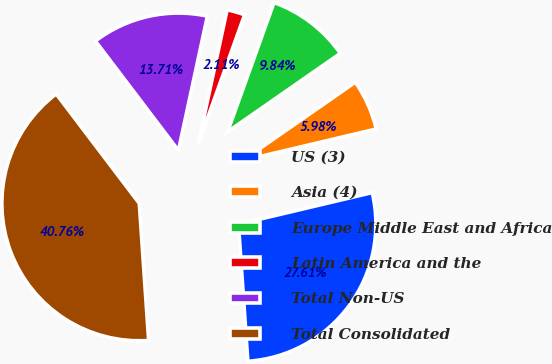Convert chart to OTSL. <chart><loc_0><loc_0><loc_500><loc_500><pie_chart><fcel>US (3)<fcel>Asia (4)<fcel>Europe Middle East and Africa<fcel>Latin America and the<fcel>Total Non-US<fcel>Total Consolidated<nl><fcel>27.61%<fcel>5.98%<fcel>9.84%<fcel>2.11%<fcel>13.71%<fcel>40.76%<nl></chart> 